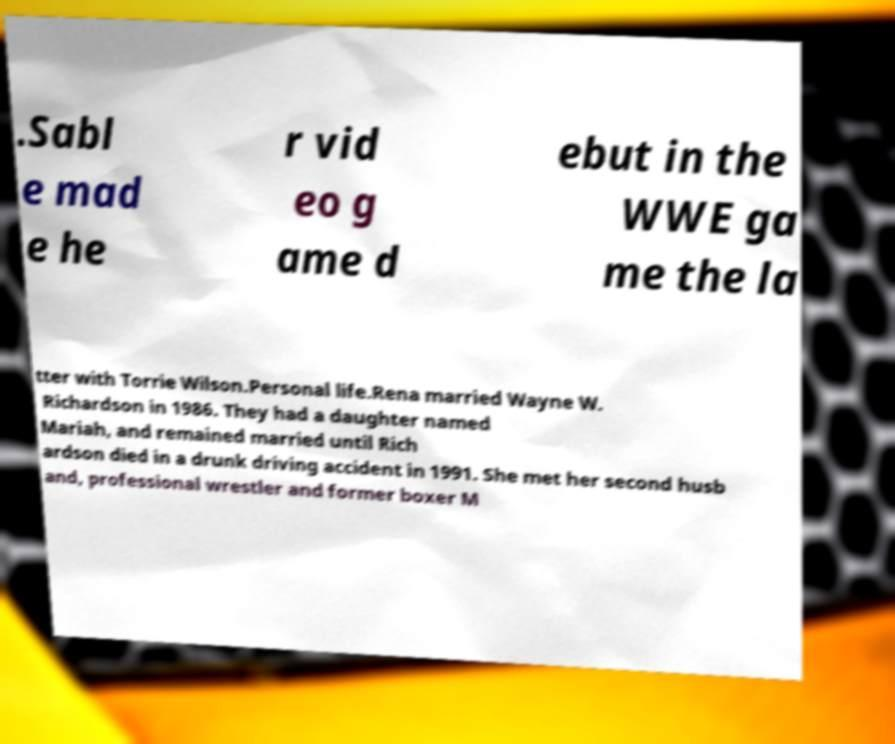For documentation purposes, I need the text within this image transcribed. Could you provide that? .Sabl e mad e he r vid eo g ame d ebut in the WWE ga me the la tter with Torrie Wilson.Personal life.Rena married Wayne W. Richardson in 1986. They had a daughter named Mariah, and remained married until Rich ardson died in a drunk driving accident in 1991. She met her second husb and, professional wrestler and former boxer M 